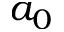<formula> <loc_0><loc_0><loc_500><loc_500>a _ { 0 }</formula> 